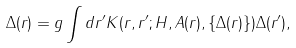Convert formula to latex. <formula><loc_0><loc_0><loc_500><loc_500>\Delta ( { r } ) = g \int d { r ^ { \prime } } K ( { r } , { r ^ { \prime } } ; H , { A } ( { r } ) , \{ \Delta ( { r } ) \} ) \Delta ( { r ^ { \prime } } ) ,</formula> 